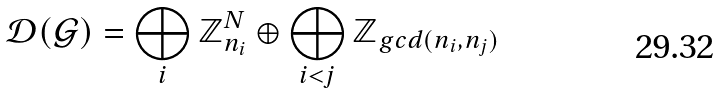<formula> <loc_0><loc_0><loc_500><loc_500>\mathcal { D } ( \mathcal { G } ) = \bigoplus _ { i } \mathbb { Z } _ { n _ { i } } ^ { N } \oplus \bigoplus _ { i < j } \mathbb { Z } _ { g c d ( n _ { i } , n _ { j } ) }</formula> 